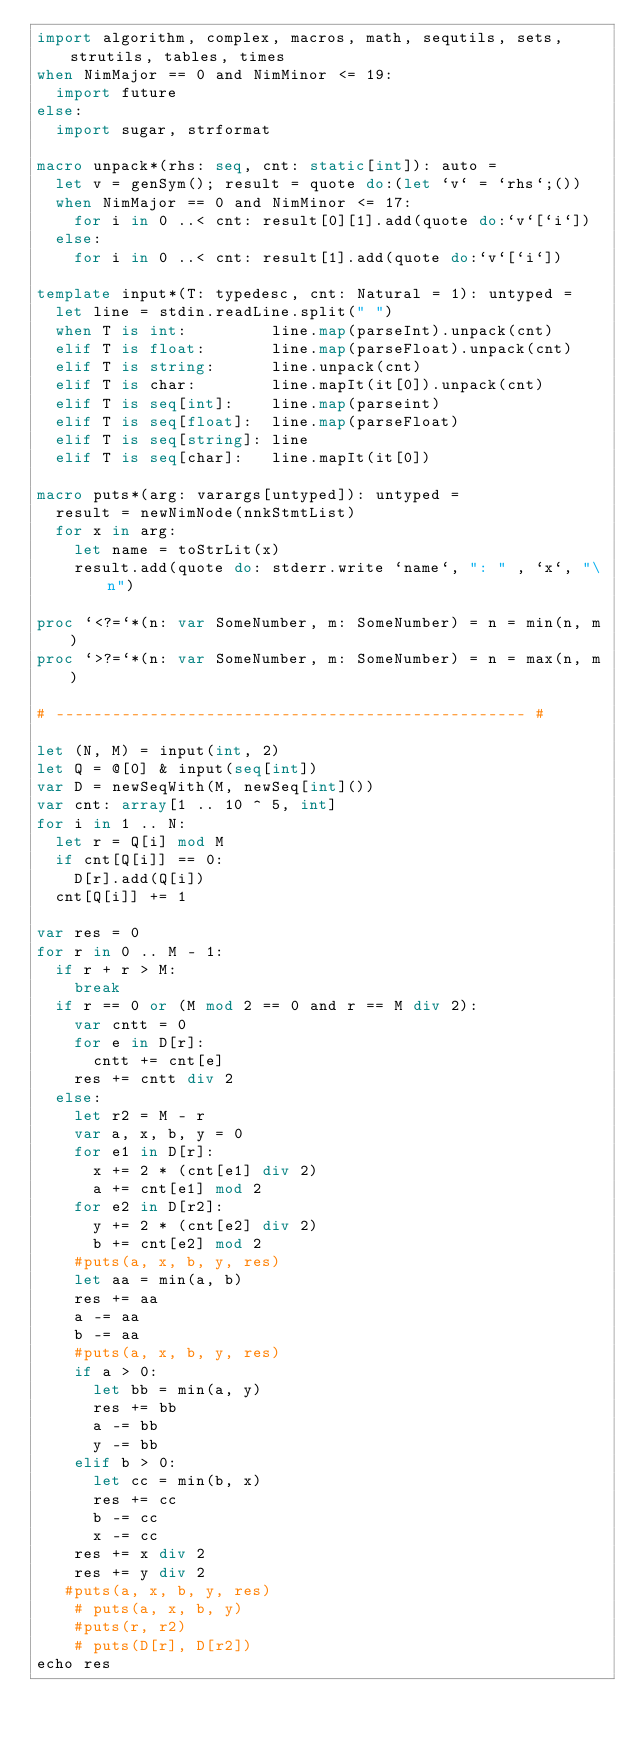<code> <loc_0><loc_0><loc_500><loc_500><_Nim_>import algorithm, complex, macros, math, sequtils, sets, strutils, tables, times
when NimMajor == 0 and NimMinor <= 19:
  import future
else:
  import sugar, strformat

macro unpack*(rhs: seq, cnt: static[int]): auto =
  let v = genSym(); result = quote do:(let `v` = `rhs`;())
  when NimMajor == 0 and NimMinor <= 17:
    for i in 0 ..< cnt: result[0][1].add(quote do:`v`[`i`])
  else:
    for i in 0 ..< cnt: result[1].add(quote do:`v`[`i`])

template input*(T: typedesc, cnt: Natural = 1): untyped =
  let line = stdin.readLine.split(" ")
  when T is int:         line.map(parseInt).unpack(cnt)
  elif T is float:       line.map(parseFloat).unpack(cnt)
  elif T is string:      line.unpack(cnt)
  elif T is char:        line.mapIt(it[0]).unpack(cnt)
  elif T is seq[int]:    line.map(parseint)
  elif T is seq[float]:  line.map(parseFloat)
  elif T is seq[string]: line
  elif T is seq[char]:   line.mapIt(it[0])

macro puts*(arg: varargs[untyped]): untyped =
  result = newNimNode(nnkStmtList)
  for x in arg:
    let name = toStrLit(x)
    result.add(quote do: stderr.write `name`, ": " , `x`, "\n")

proc `<?=`*(n: var SomeNumber, m: SomeNumber) = n = min(n, m)
proc `>?=`*(n: var SomeNumber, m: SomeNumber) = n = max(n, m)

# -------------------------------------------------- #

let (N, M) = input(int, 2)
let Q = @[0] & input(seq[int])
var D = newSeqWith(M, newSeq[int]())
var cnt: array[1 .. 10 ^ 5, int]
for i in 1 .. N:
  let r = Q[i] mod M
  if cnt[Q[i]] == 0:
    D[r].add(Q[i])
  cnt[Q[i]] += 1

var res = 0
for r in 0 .. M - 1:
  if r + r > M:
    break
  if r == 0 or (M mod 2 == 0 and r == M div 2):
    var cntt = 0
    for e in D[r]:
      cntt += cnt[e]
    res += cntt div 2
  else:
    let r2 = M - r
    var a, x, b, y = 0
    for e1 in D[r]:
      x += 2 * (cnt[e1] div 2)
      a += cnt[e1] mod 2
    for e2 in D[r2]:
      y += 2 * (cnt[e2] div 2)
      b += cnt[e2] mod 2
    #puts(a, x, b, y, res)
    let aa = min(a, b)
    res += aa
    a -= aa
    b -= aa
    #puts(a, x, b, y, res)
    if a > 0:
      let bb = min(a, y)
      res += bb
      a -= bb
      y -= bb
    elif b > 0:
      let cc = min(b, x)
      res += cc
      b -= cc
      x -= cc
    res += x div 2
    res += y div 2
   #puts(a, x, b, y, res)
    # puts(a, x, b, y)
    #puts(r, r2)
    # puts(D[r], D[r2])
echo res</code> 